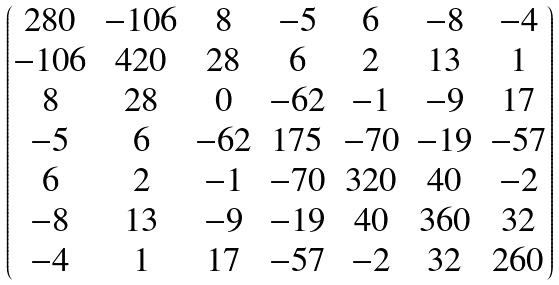Convert formula to latex. <formula><loc_0><loc_0><loc_500><loc_500>\begin{pmatrix} 2 8 0 & - 1 0 6 & 8 & - 5 & 6 & - 8 & - 4 \\ - 1 0 6 & 4 2 0 & 2 8 & 6 & 2 & 1 3 & 1 \\ 8 & 2 8 & 0 & - 6 2 & - 1 & - 9 & 1 7 \\ - 5 & 6 & - 6 2 & 1 7 5 & - 7 0 & - 1 9 & - 5 7 \\ 6 & 2 & - 1 & - 7 0 & 3 2 0 & 4 0 & - 2 \\ - 8 & 1 3 & - 9 & - 1 9 & 4 0 & 3 6 0 & 3 2 \\ - 4 & 1 & 1 7 & - 5 7 & - 2 & 3 2 & 2 6 0 \end{pmatrix}</formula> 